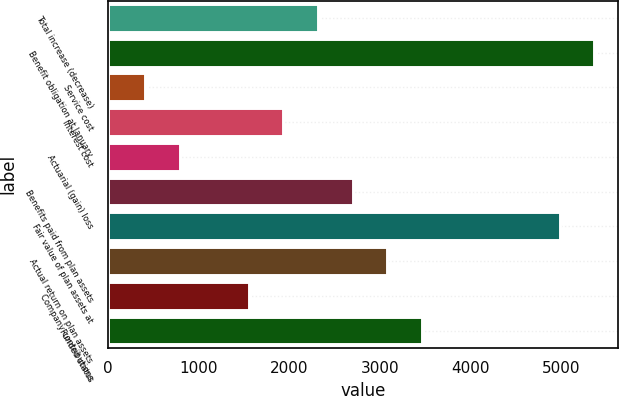Convert chart to OTSL. <chart><loc_0><loc_0><loc_500><loc_500><bar_chart><fcel>Total increase (decrease)<fcel>Benefit obligation at January<fcel>Service cost<fcel>Interest cost<fcel>Actuarial (gain) loss<fcel>Benefits paid from plan assets<fcel>Fair value of plan assets at<fcel>Actual return on plan assets<fcel>Company contributions<fcel>Funded status<nl><fcel>2319.6<fcel>5364.4<fcel>416.6<fcel>1939<fcel>797.2<fcel>2700.2<fcel>4983.8<fcel>3080.8<fcel>1558.4<fcel>3461.4<nl></chart> 